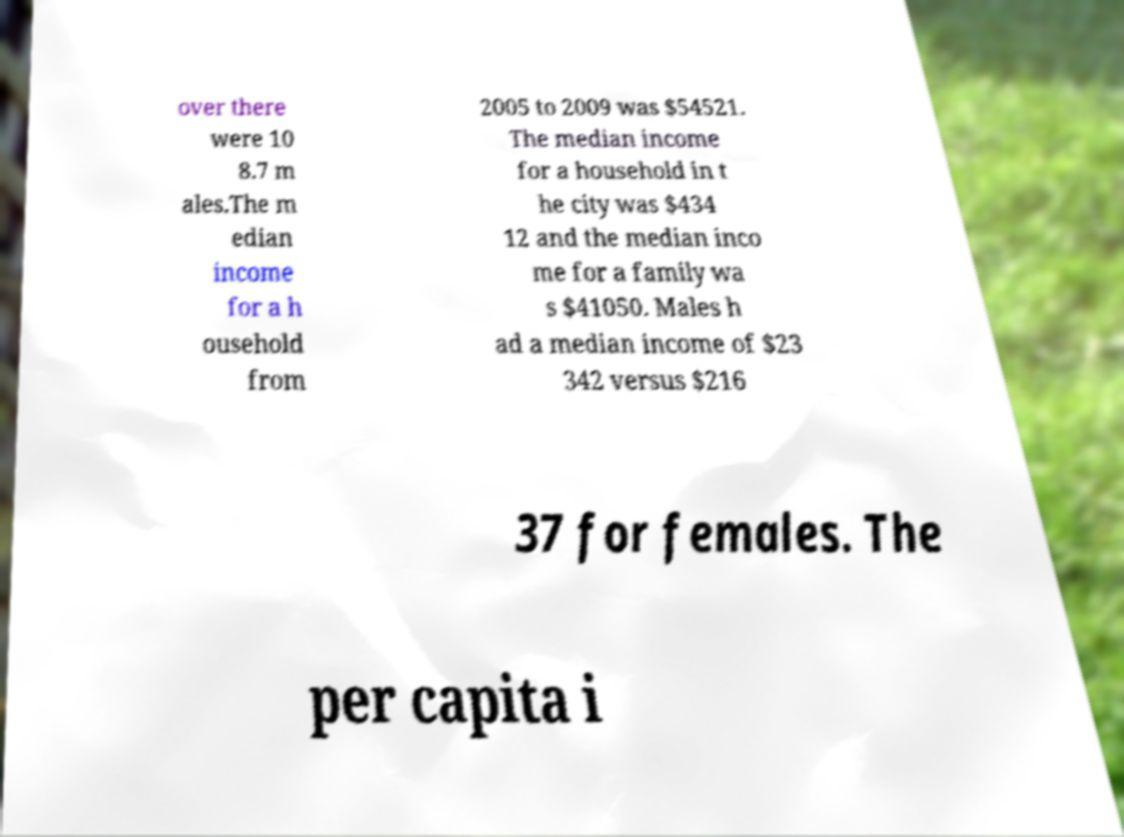Please identify and transcribe the text found in this image. over there were 10 8.7 m ales.The m edian income for a h ousehold from 2005 to 2009 was $54521. The median income for a household in t he city was $434 12 and the median inco me for a family wa s $41050. Males h ad a median income of $23 342 versus $216 37 for females. The per capita i 